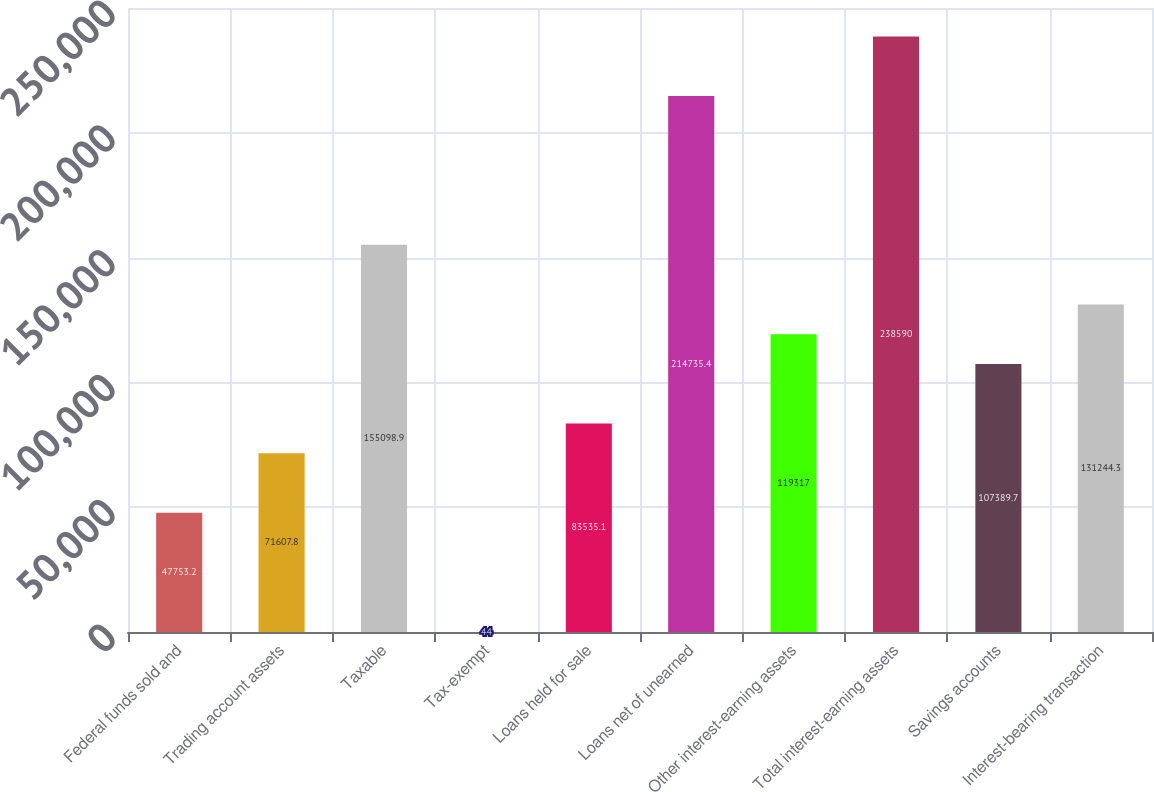<chart> <loc_0><loc_0><loc_500><loc_500><bar_chart><fcel>Federal funds sold and<fcel>Trading account assets<fcel>Taxable<fcel>Tax-exempt<fcel>Loans held for sale<fcel>Loans net of unearned<fcel>Other interest-earning assets<fcel>Total interest-earning assets<fcel>Savings accounts<fcel>Interest-bearing transaction<nl><fcel>47753.2<fcel>71607.8<fcel>155099<fcel>44<fcel>83535.1<fcel>214735<fcel>119317<fcel>238590<fcel>107390<fcel>131244<nl></chart> 